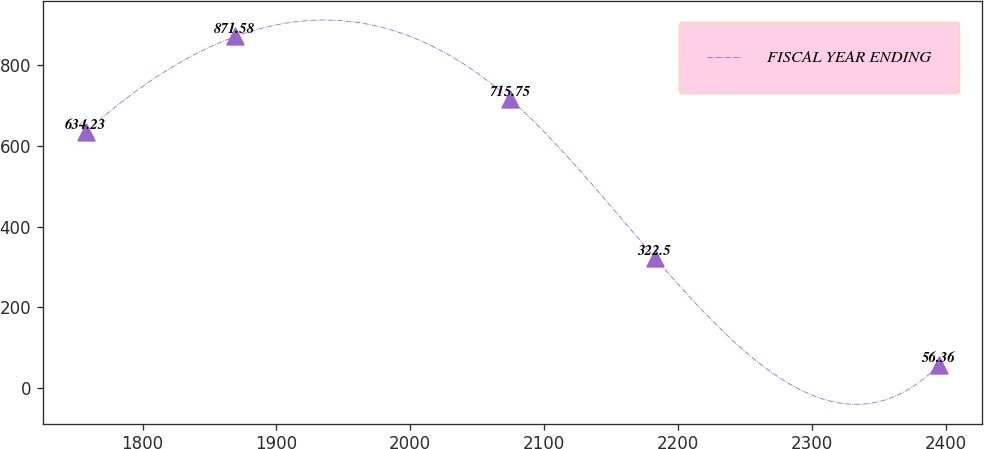<chart> <loc_0><loc_0><loc_500><loc_500><line_chart><ecel><fcel>FISCAL YEAR ENDING<nl><fcel>1757.4<fcel>634.23<nl><fcel>1869.22<fcel>871.58<nl><fcel>2074.72<fcel>715.75<nl><fcel>2182.9<fcel>322.5<nl><fcel>2394.98<fcel>56.36<nl></chart> 